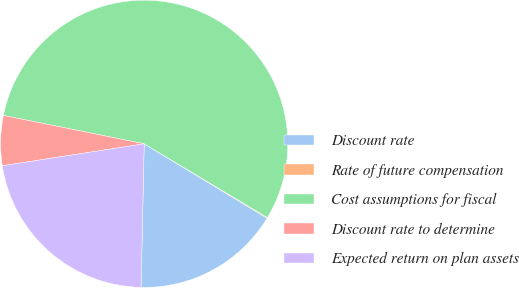Convert chart to OTSL. <chart><loc_0><loc_0><loc_500><loc_500><pie_chart><fcel>Discount rate<fcel>Rate of future compensation<fcel>Cost assumptions for fiscal<fcel>Discount rate to determine<fcel>Expected return on plan assets<nl><fcel>16.68%<fcel>0.08%<fcel>55.42%<fcel>5.61%<fcel>22.21%<nl></chart> 